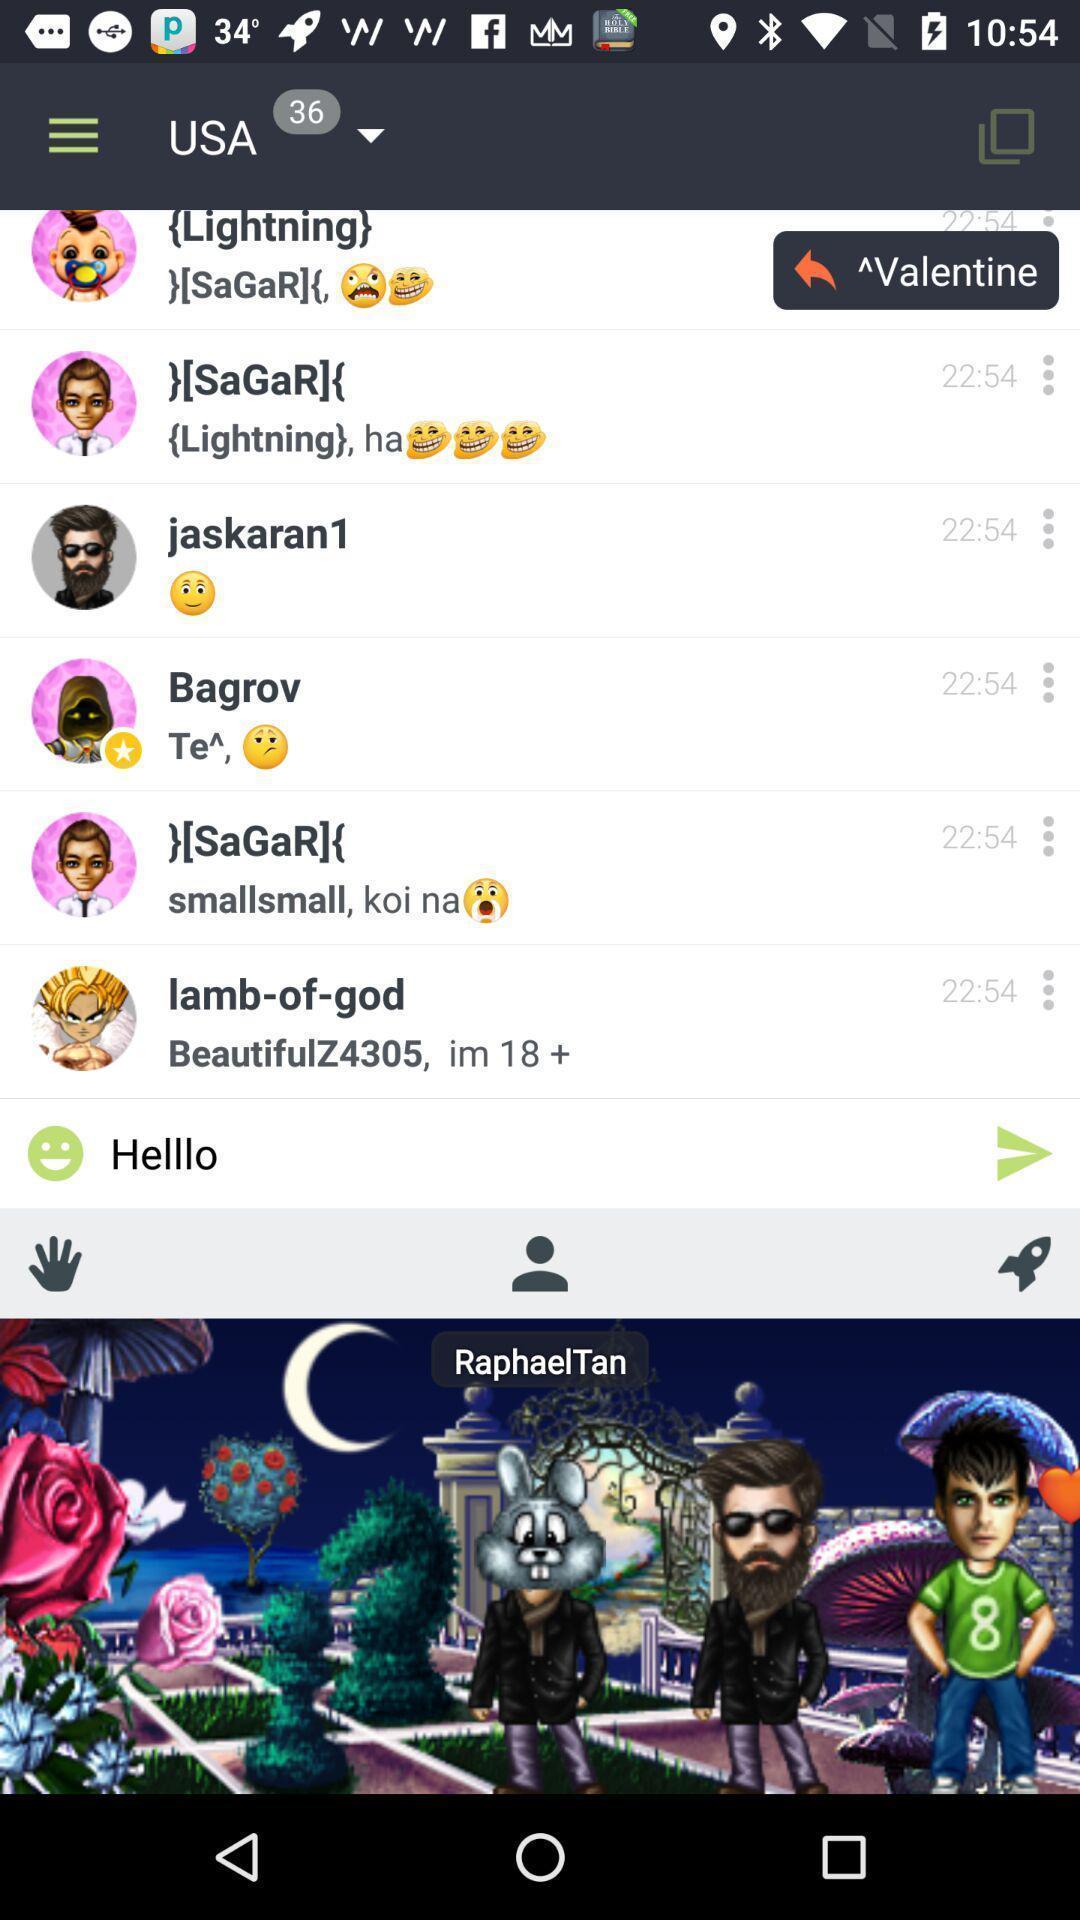Tell me what you see in this picture. Screen displaying the page of a social app. 